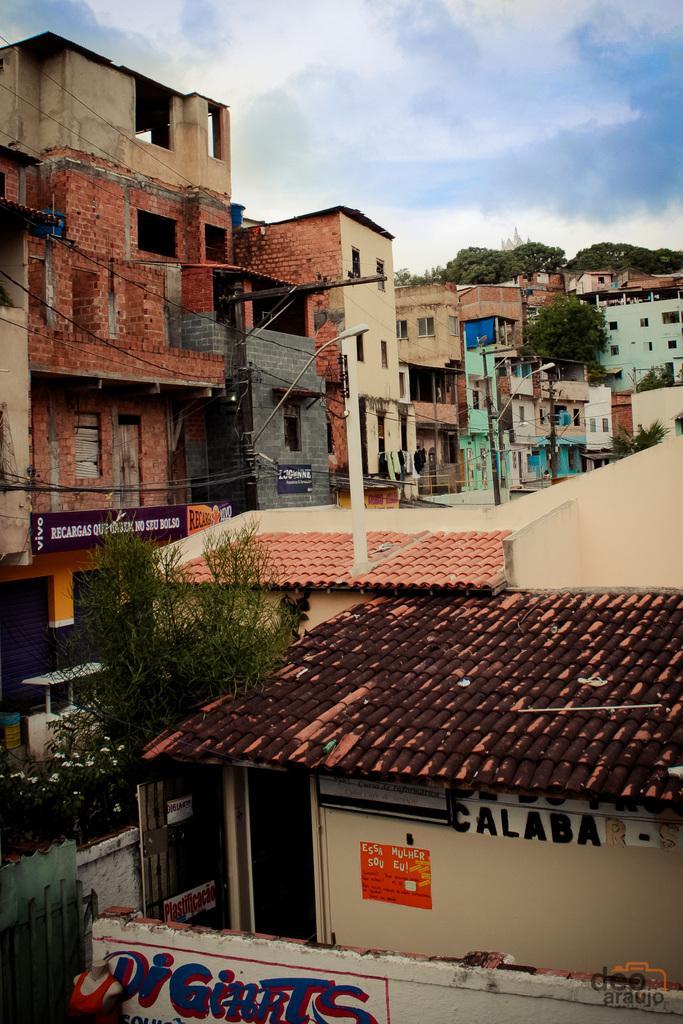In one or two sentences, can you explain what this image depicts? These are the houses with windows. I can see a poster attached to the wall. This looks like a gate. I can see a plant with flowers. These are the trees. I can see street lights and the current poles with the current wires hanging. This looks like a name board, which is attached to the wall. 